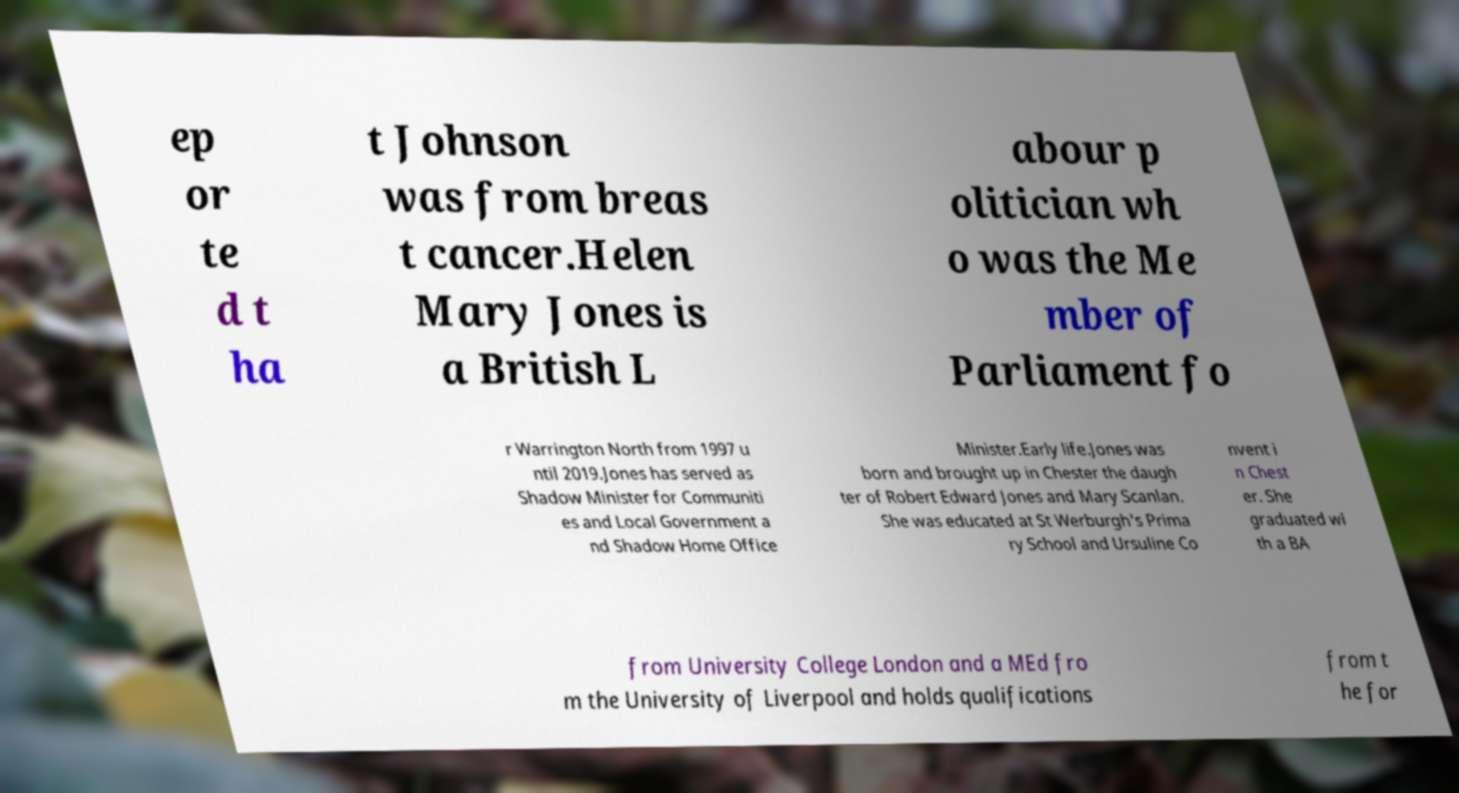Could you assist in decoding the text presented in this image and type it out clearly? ep or te d t ha t Johnson was from breas t cancer.Helen Mary Jones is a British L abour p olitician wh o was the Me mber of Parliament fo r Warrington North from 1997 u ntil 2019.Jones has served as Shadow Minister for Communiti es and Local Government a nd Shadow Home Office Minister.Early life.Jones was born and brought up in Chester the daugh ter of Robert Edward Jones and Mary Scanlan. She was educated at St Werburgh's Prima ry School and Ursuline Co nvent i n Chest er. She graduated wi th a BA from University College London and a MEd fro m the University of Liverpool and holds qualifications from t he for 